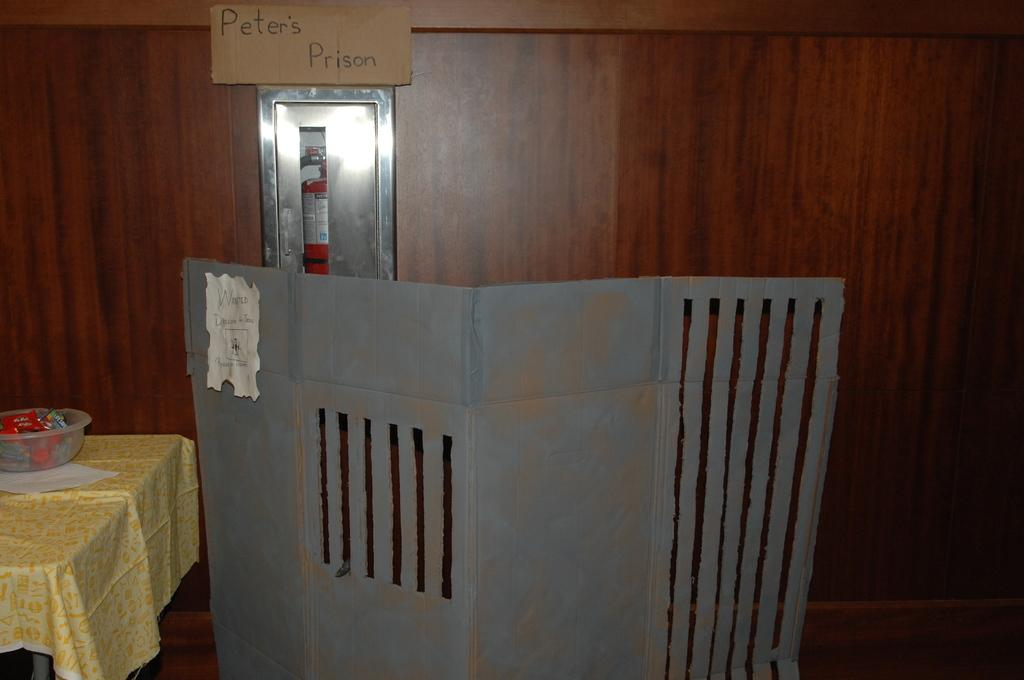Provide a one-sentence caption for the provided image. a sign says Peter's Prison above a cardboard prison gate. 